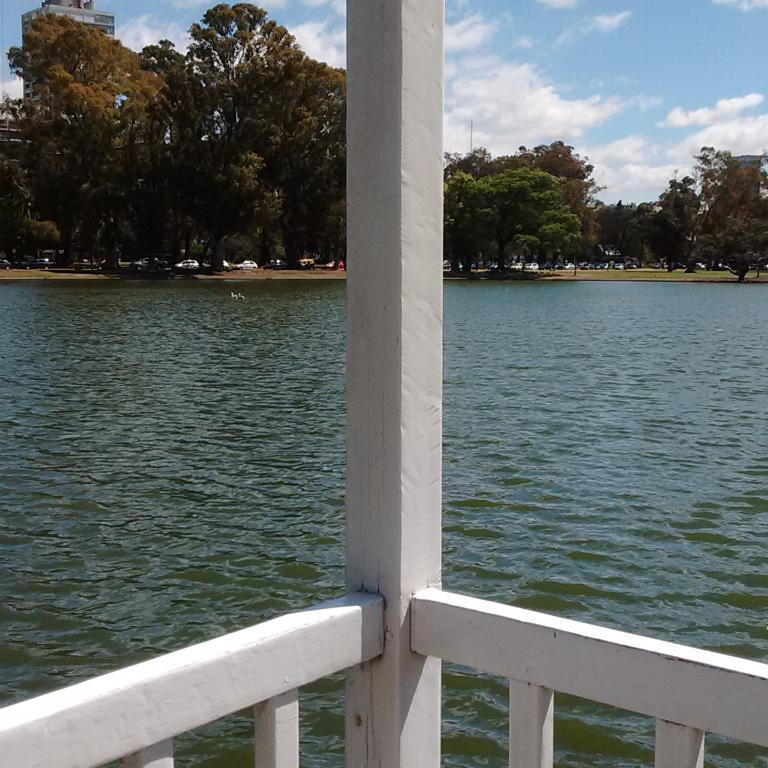What type of barrier can be seen in the image? There is a wooden fence in the image. What natural feature is present in the image? There is a lake in the image. What can be seen in the background of the image? Trees, vehicles, the sky, and a building are visible in the background of the image. What type of salt is being used to write the caption on the image? There is no salt or caption present in the image. How many cars are visible in the image? There is no car present in the image; only vehicles are mentioned in the background. 